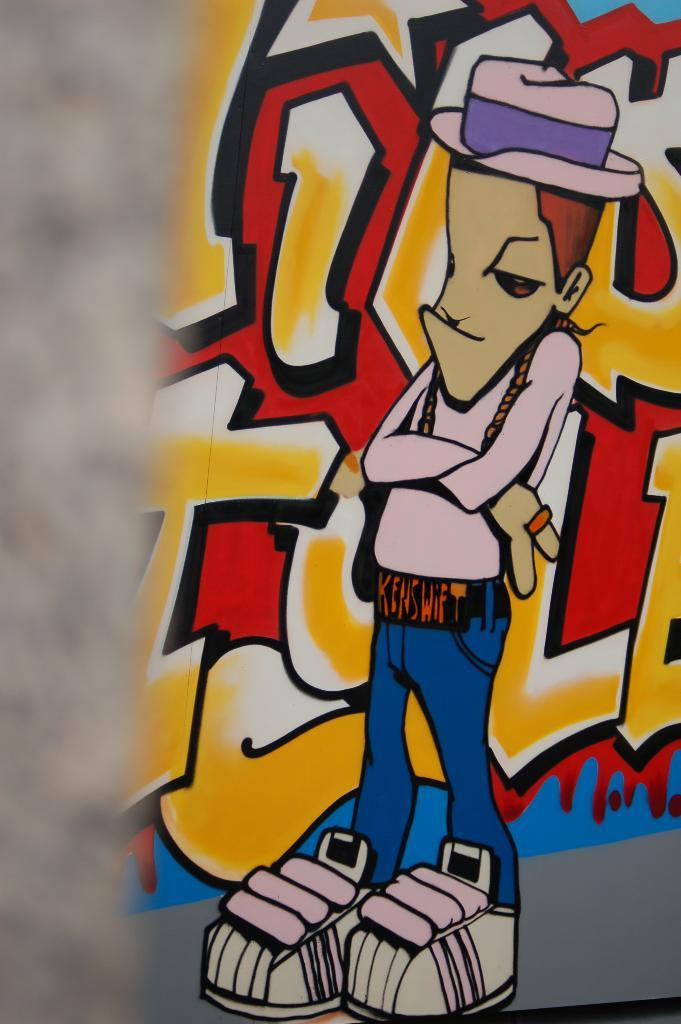What is the main subject of the image? There is a graffiti painting in the image. Can you hear the music being played by the toad in the image? There is no toad or music present in the image; it features a graffiti painting. 